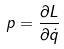Convert formula to latex. <formula><loc_0><loc_0><loc_500><loc_500>p = \frac { \partial L } { \partial \dot { q } }</formula> 